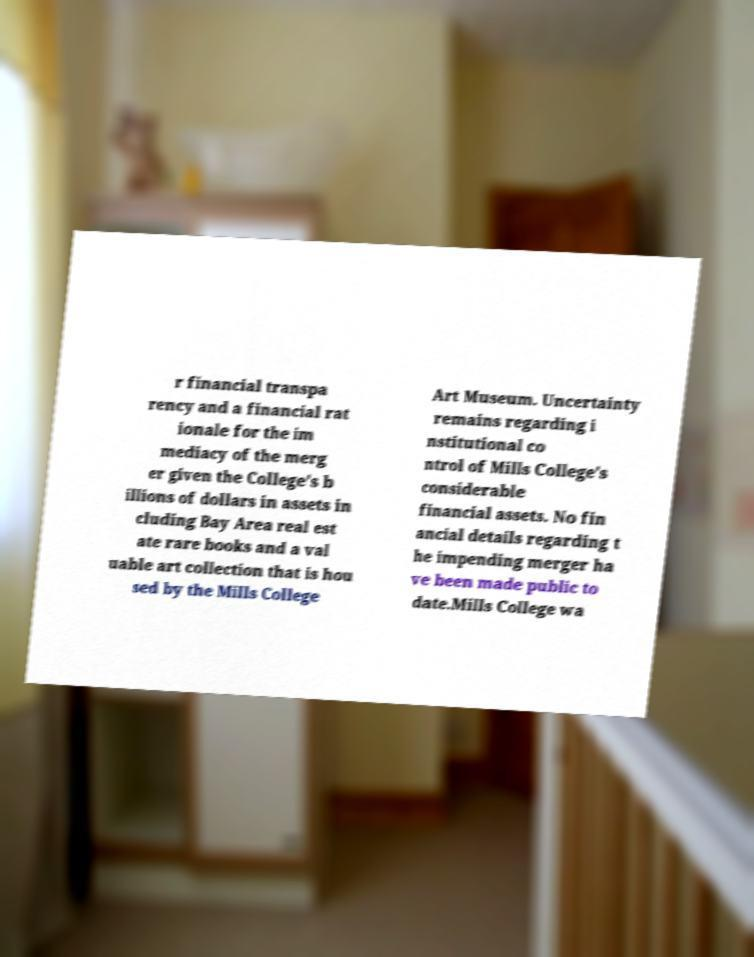Can you read and provide the text displayed in the image?This photo seems to have some interesting text. Can you extract and type it out for me? r financial transpa rency and a financial rat ionale for the im mediacy of the merg er given the College's b illions of dollars in assets in cluding Bay Area real est ate rare books and a val uable art collection that is hou sed by the Mills College Art Museum. Uncertainty remains regarding i nstitutional co ntrol of Mills College's considerable financial assets. No fin ancial details regarding t he impending merger ha ve been made public to date.Mills College wa 